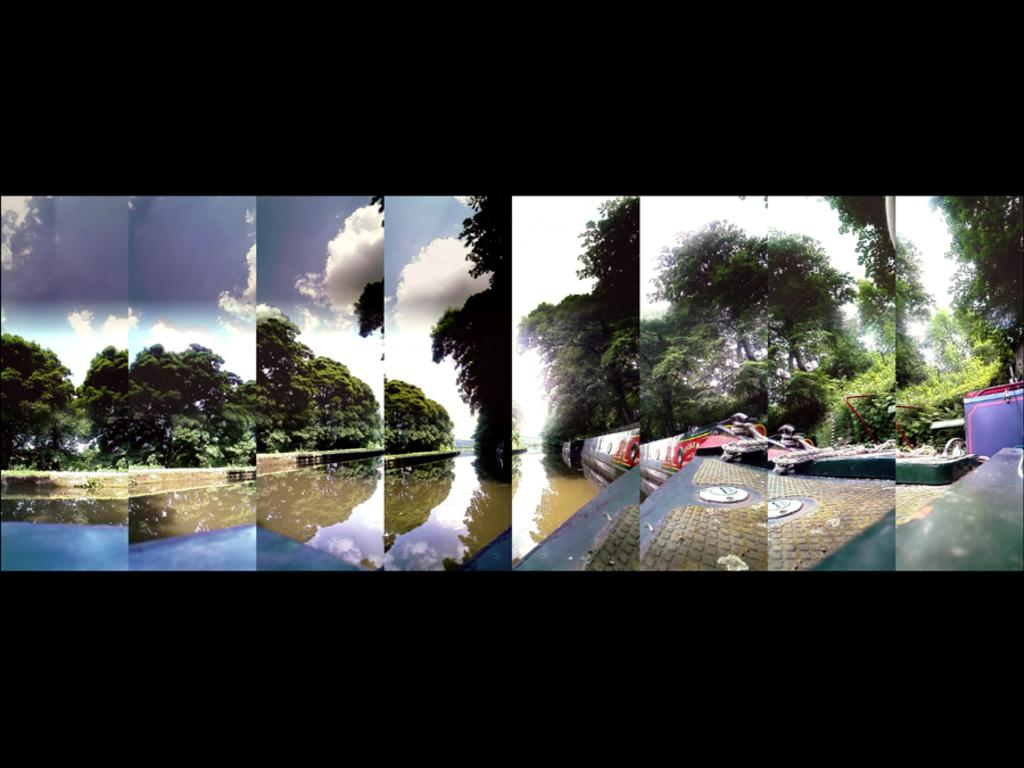What type of artwork is depicted in the image? The image is a collage of images. What natural elements can be seen in the collage? There are trees, water, and clouds in the collage. What type of stone is used to build the nation's capital in the image? There is no mention of a nation's capital or any stone in the image; it is a collage of images featuring trees, water, and clouds. Can you see any cows in the image? There are no cows present in the image. 